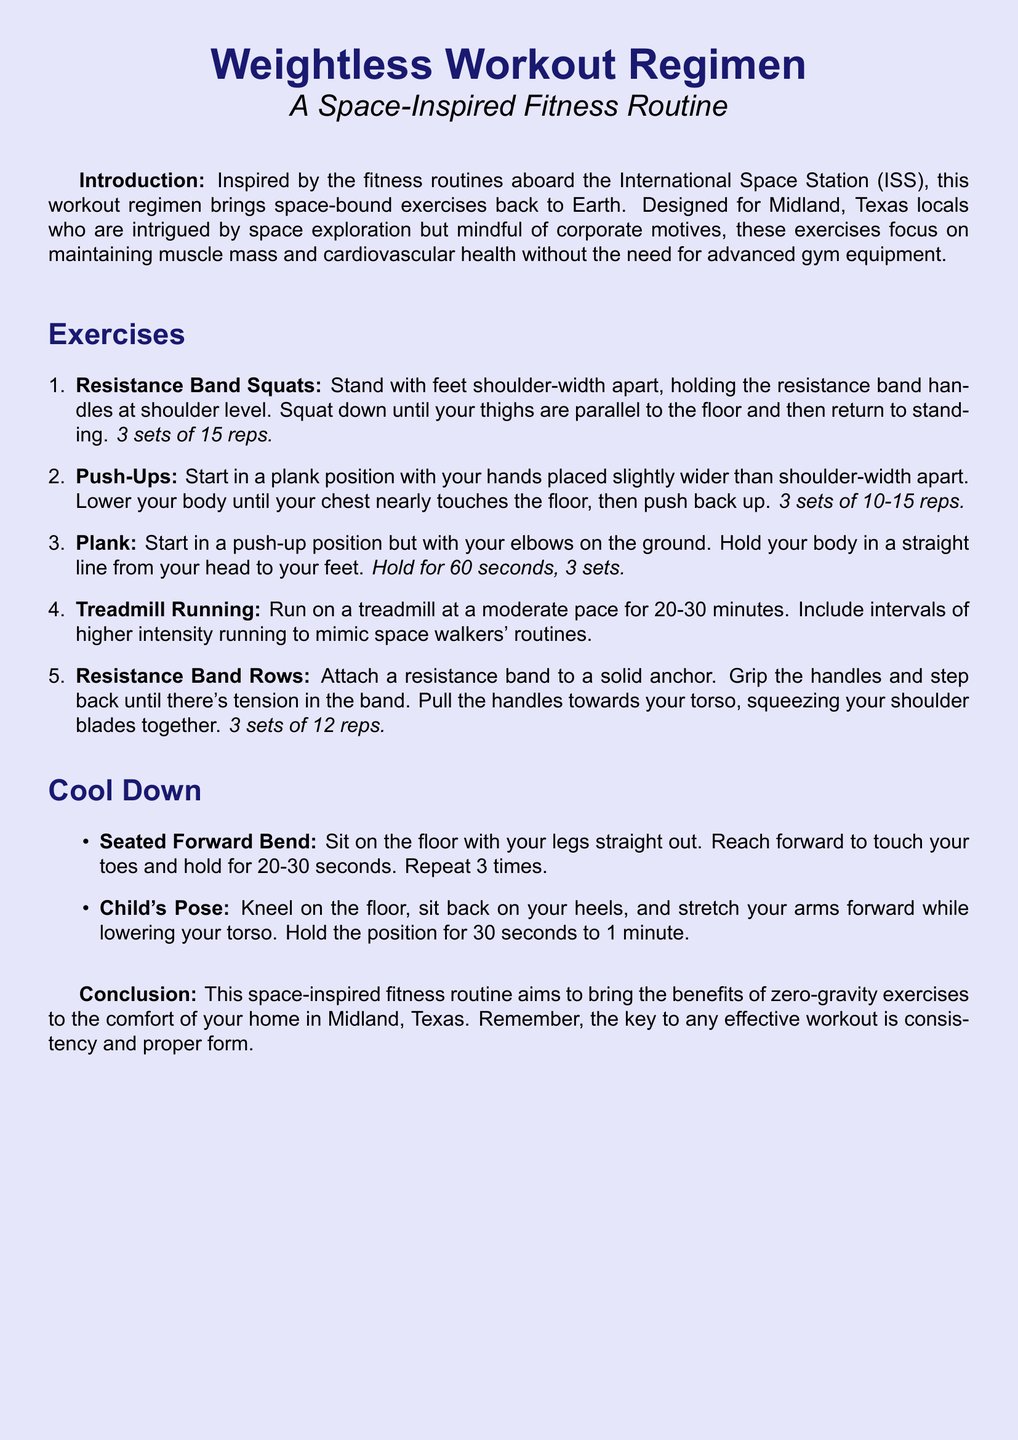What is the title of the workout regimen? The title is indicated at the top of the document, highlighted as "Weightless Workout Regimen."
Answer: Weightless Workout Regimen How many sets of resistance band squats are recommended? The document specifies "3 sets of 15 reps" for resistance band squats.
Answer: 3 sets of 15 reps What is the duration suggested for treadmill running? The document states a duration of "20-30 minutes" for treadmill running.
Answer: 20-30 minutes What exercise is recommended for a cool down? The document lists "Seated Forward Bend" and "Child's Pose" as cool-down exercises.
Answer: Seated Forward Bend, Child's Pose How long should you hold the plank? The document specifies to "Hold for 60 seconds, 3 sets" for the plank exercise.
Answer: 60 seconds What is the main goal of this workout regimen? The introduction indicates the goal is to "maintain muscle mass and cardiovascular health."
Answer: Maintain muscle mass and cardiovascular health What type of band is suggested for rows? The document refers to using a "resistance band" for rows.
Answer: Resistance band How many repetitions are suggested for resistance band rows? The document indicates "3 sets of 12 reps" for resistance band rows.
Answer: 3 sets of 12 reps 